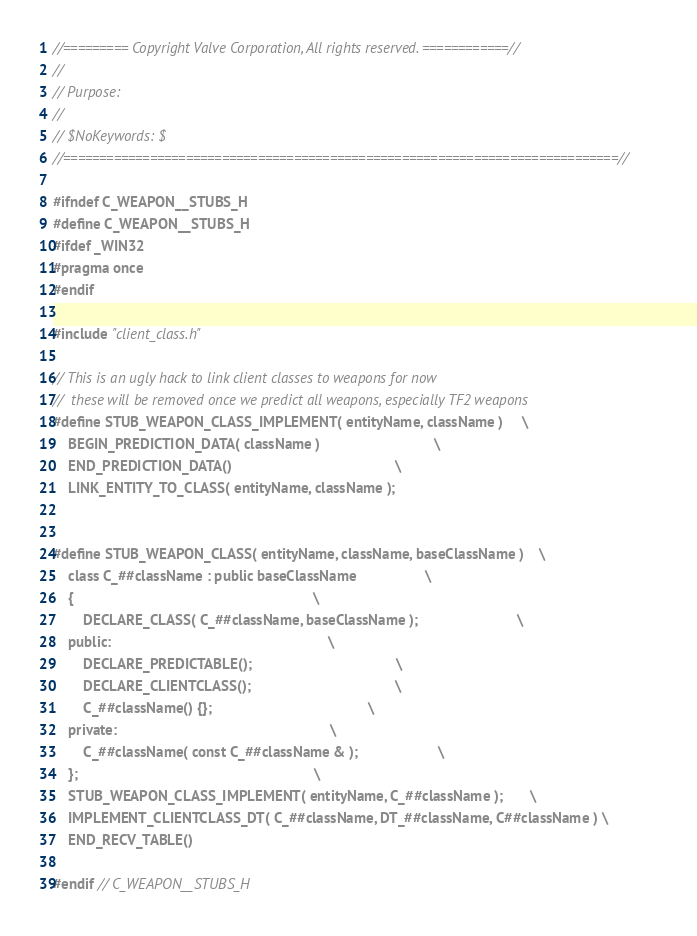<code> <loc_0><loc_0><loc_500><loc_500><_C_>//========= Copyright Valve Corporation, All rights reserved. ============//
//
// Purpose: 
//
// $NoKeywords: $
//=============================================================================//

#ifndef C_WEAPON__STUBS_H
#define C_WEAPON__STUBS_H
#ifdef _WIN32
#pragma once
#endif

#include "client_class.h"

// This is an ugly hack to link client classes to weapons for now
//  these will be removed once we predict all weapons, especially TF2 weapons
#define STUB_WEAPON_CLASS_IMPLEMENT( entityName, className )		\
	BEGIN_PREDICTION_DATA( className )								\
	END_PREDICTION_DATA()											\
	LINK_ENTITY_TO_CLASS( entityName, className );


#define STUB_WEAPON_CLASS( entityName, className, baseClassName )	\
	class C_##className : public baseClassName					\
	{																\
		DECLARE_CLASS( C_##className, baseClassName );							\
	public:															\
		DECLARE_PREDICTABLE();										\
		DECLARE_CLIENTCLASS();										\
		C_##className() {};											\
	private:														\
		C_##className( const C_##className & );						\
	};																\
	STUB_WEAPON_CLASS_IMPLEMENT( entityName, C_##className );		\
	IMPLEMENT_CLIENTCLASS_DT( C_##className, DT_##className, C##className )	\
	END_RECV_TABLE()

#endif // C_WEAPON__STUBS_H
</code> 